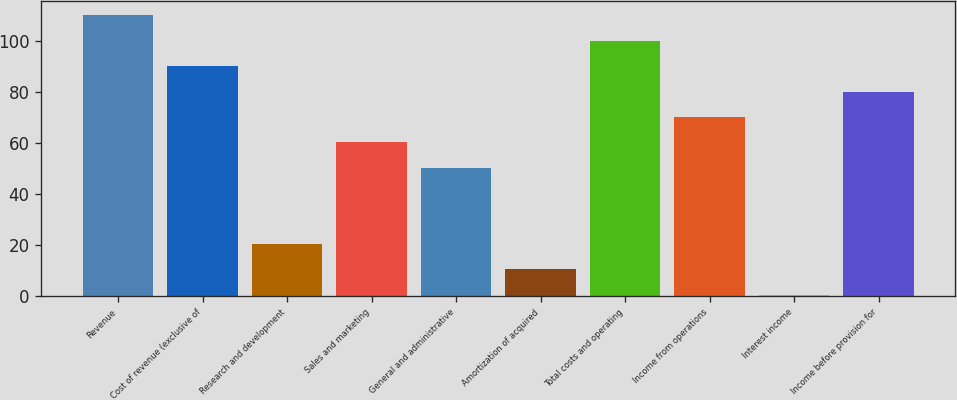Convert chart to OTSL. <chart><loc_0><loc_0><loc_500><loc_500><bar_chart><fcel>Revenue<fcel>Cost of revenue (exclusive of<fcel>Research and development<fcel>Sales and marketing<fcel>General and administrative<fcel>Amortization of acquired<fcel>Total costs and operating<fcel>Income from operations<fcel>Interest income<fcel>Income before provision for<nl><fcel>109.95<fcel>90.05<fcel>20.4<fcel>60.2<fcel>50.25<fcel>10.45<fcel>100<fcel>70.15<fcel>0.5<fcel>80.1<nl></chart> 